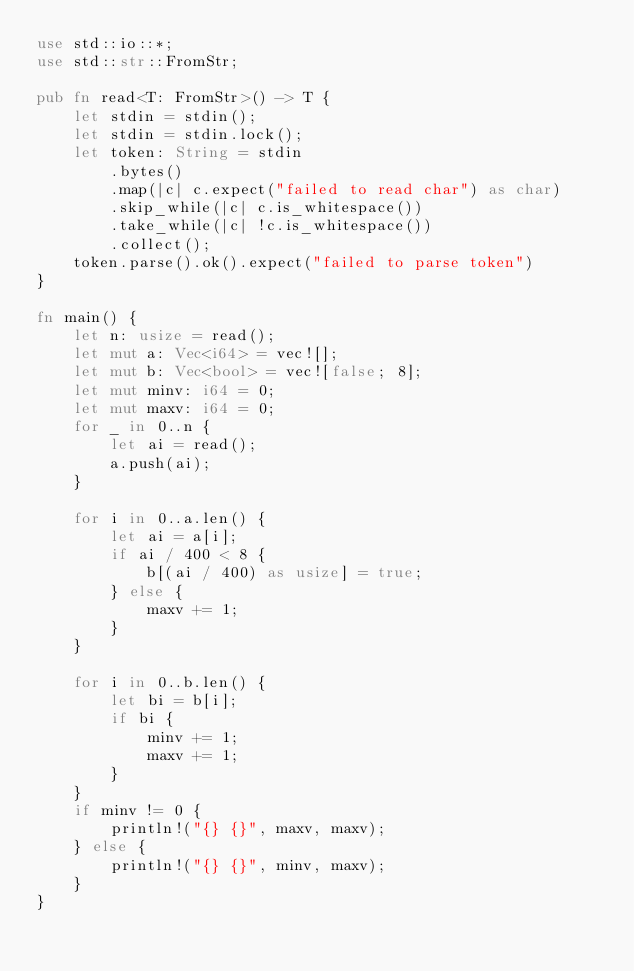Convert code to text. <code><loc_0><loc_0><loc_500><loc_500><_Rust_>use std::io::*;
use std::str::FromStr;

pub fn read<T: FromStr>() -> T {
    let stdin = stdin();
    let stdin = stdin.lock();
    let token: String = stdin
        .bytes()
        .map(|c| c.expect("failed to read char") as char)
        .skip_while(|c| c.is_whitespace())
        .take_while(|c| !c.is_whitespace())
        .collect();
    token.parse().ok().expect("failed to parse token")
}

fn main() {
    let n: usize = read();
    let mut a: Vec<i64> = vec![];
    let mut b: Vec<bool> = vec![false; 8];
    let mut minv: i64 = 0;
    let mut maxv: i64 = 0;
    for _ in 0..n {
        let ai = read();
        a.push(ai);
    }

    for i in 0..a.len() {
        let ai = a[i];
        if ai / 400 < 8 {
            b[(ai / 400) as usize] = true;
        } else {
            maxv += 1;
        }
    }

    for i in 0..b.len() {
        let bi = b[i];
        if bi {
            minv += 1;
            maxv += 1;
        }
    }
    if minv != 0 {
        println!("{} {}", maxv, maxv);
    } else {
        println!("{} {}", minv, maxv);
    }
}
</code> 